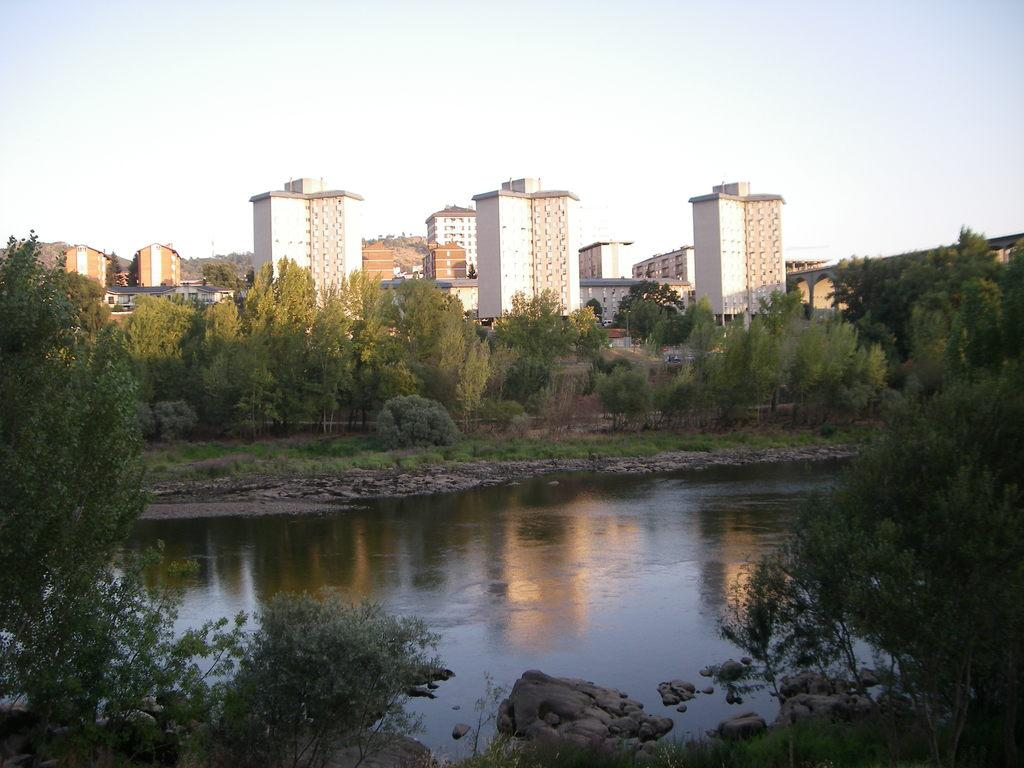What type of structures can be seen in the image? There is a group of buildings in the image. What type of vegetation is present in the image? There are trees and grass in the image. What natural feature can be seen in the image? There is a water body in the image. What type of terrain is visible in the image? There are stones and hills in the image. What is the condition of the sky in the image? The sky is visible in the image and appears cloudy. Can you tell me how many bears are visible in the image? There are no bears present in the image. What type of credit or account can be seen in the image? There is no credit or account visible in the image; it features a group of buildings, trees, grass, a water body, stones, hills, and a cloudy sky. 